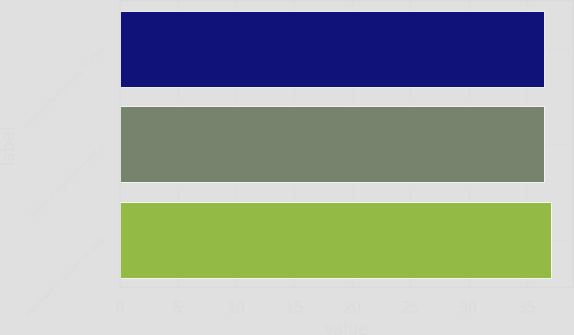Convert chart. <chart><loc_0><loc_0><loc_500><loc_500><bar_chart><fcel>Outstanding at January 30 2016<fcel>Vested or expected to vest at<fcel>Exercisable at January 30 2016<nl><fcel>36.53<fcel>36.47<fcel>37.09<nl></chart> 